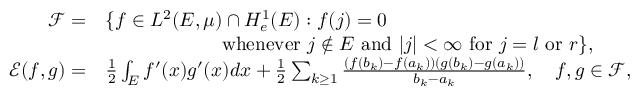Convert formula to latex. <formula><loc_0><loc_0><loc_500><loc_500>\begin{array} { r l } { { \ m a t h s c r F } = } & { \{ f \in L ^ { 2 } ( E , \mu ) \cap H _ { e } ^ { 1 } ( E ) \colon f ( j ) = 0 } \\ & { \quad w h e n e v e r j \notin E a n d | j | < \infty f o r j = l o r r \} , } \\ { { \ m a t h s c r E } ( f , g ) = } & { \frac { 1 } { 2 } \int _ { E } f ^ { \prime } ( x ) g ^ { \prime } ( x ) d x + \frac { 1 } { 2 } \sum _ { k \geq 1 } \frac { ( f ( b _ { k } ) - f ( a _ { k } ) ) ( g ( b _ { k } ) - g ( a _ { k } ) ) } { b _ { k } - a _ { k } } , \quad f , g \in { \ m a t h s c r F } , } \end{array}</formula> 